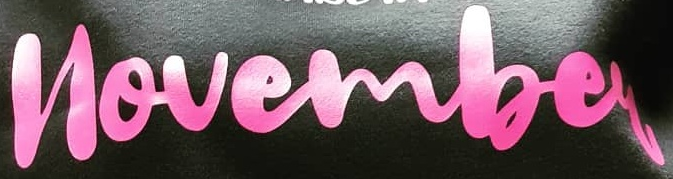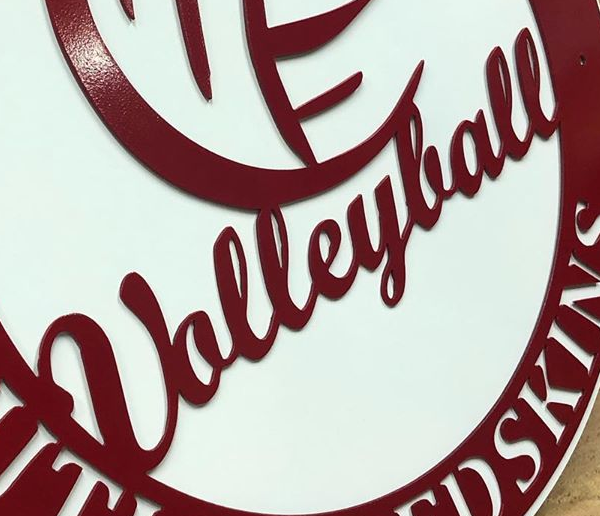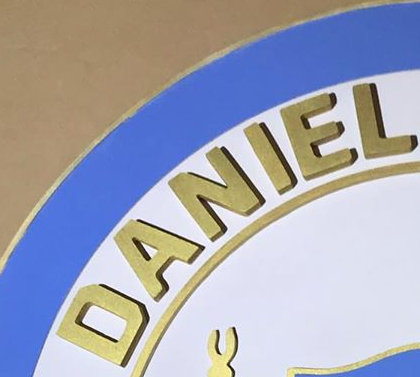Read the text content from these images in order, separated by a semicolon. novembey; Ualleylall; DANIEL 